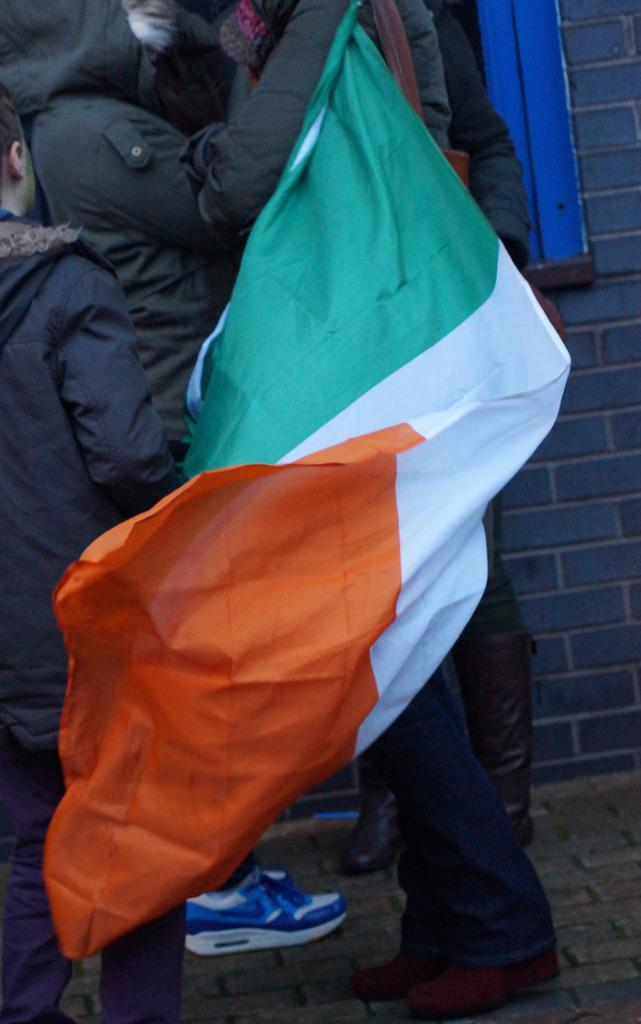Who or what is present in the image? There are people in the image. What are the people holding in the image? The people are holding an Indian flag. What can be seen in the background of the image? There is a brick wall in the background of the image. What type of hate can be seen on the faces of the people in the image? There is no indication of hate on the faces of the people in the image; they are holding an Indian flag. How much grip do the people have on the flag in the image? The question about grip is not relevant to the image, as it focuses on the people's physical interaction with the flag, which is not mentioned in the provided facts. 